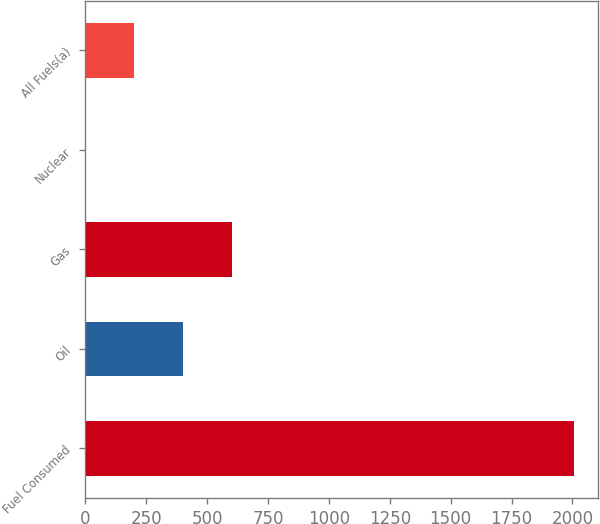Convert chart. <chart><loc_0><loc_0><loc_500><loc_500><bar_chart><fcel>Fuel Consumed<fcel>Oil<fcel>Gas<fcel>Nuclear<fcel>All Fuels(a)<nl><fcel>2005<fcel>401.28<fcel>601.75<fcel>0.34<fcel>200.81<nl></chart> 